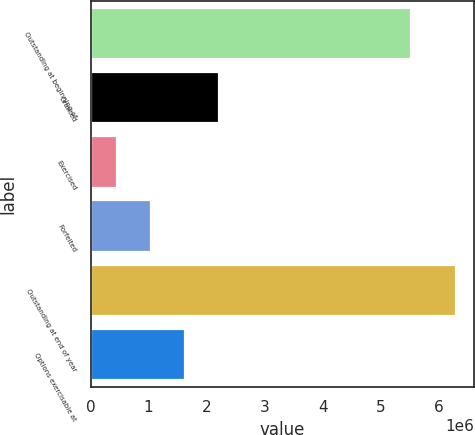Convert chart. <chart><loc_0><loc_0><loc_500><loc_500><bar_chart><fcel>Outstanding at beginning of<fcel>Granted<fcel>Exercised<fcel>Forfeited<fcel>Outstanding at end of year<fcel>Options exercisable at<nl><fcel>5.53e+06<fcel>2.20907e+06<fcel>455706<fcel>1.04016e+06<fcel>6.30026e+06<fcel>1.62462e+06<nl></chart> 